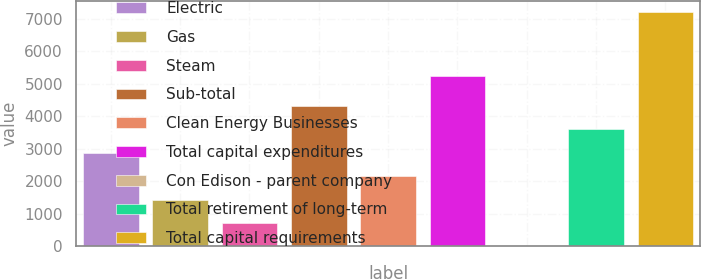Convert chart to OTSL. <chart><loc_0><loc_0><loc_500><loc_500><bar_chart><fcel>Electric<fcel>Gas<fcel>Steam<fcel>Sub-total<fcel>Clean Energy Businesses<fcel>Total capital expenditures<fcel>Con Edison - parent company<fcel>Total retirement of long-term<fcel>Total capital requirements<nl><fcel>2876<fcel>1439<fcel>720.5<fcel>4313<fcel>2157.5<fcel>5249<fcel>2<fcel>3594.5<fcel>7187<nl></chart> 